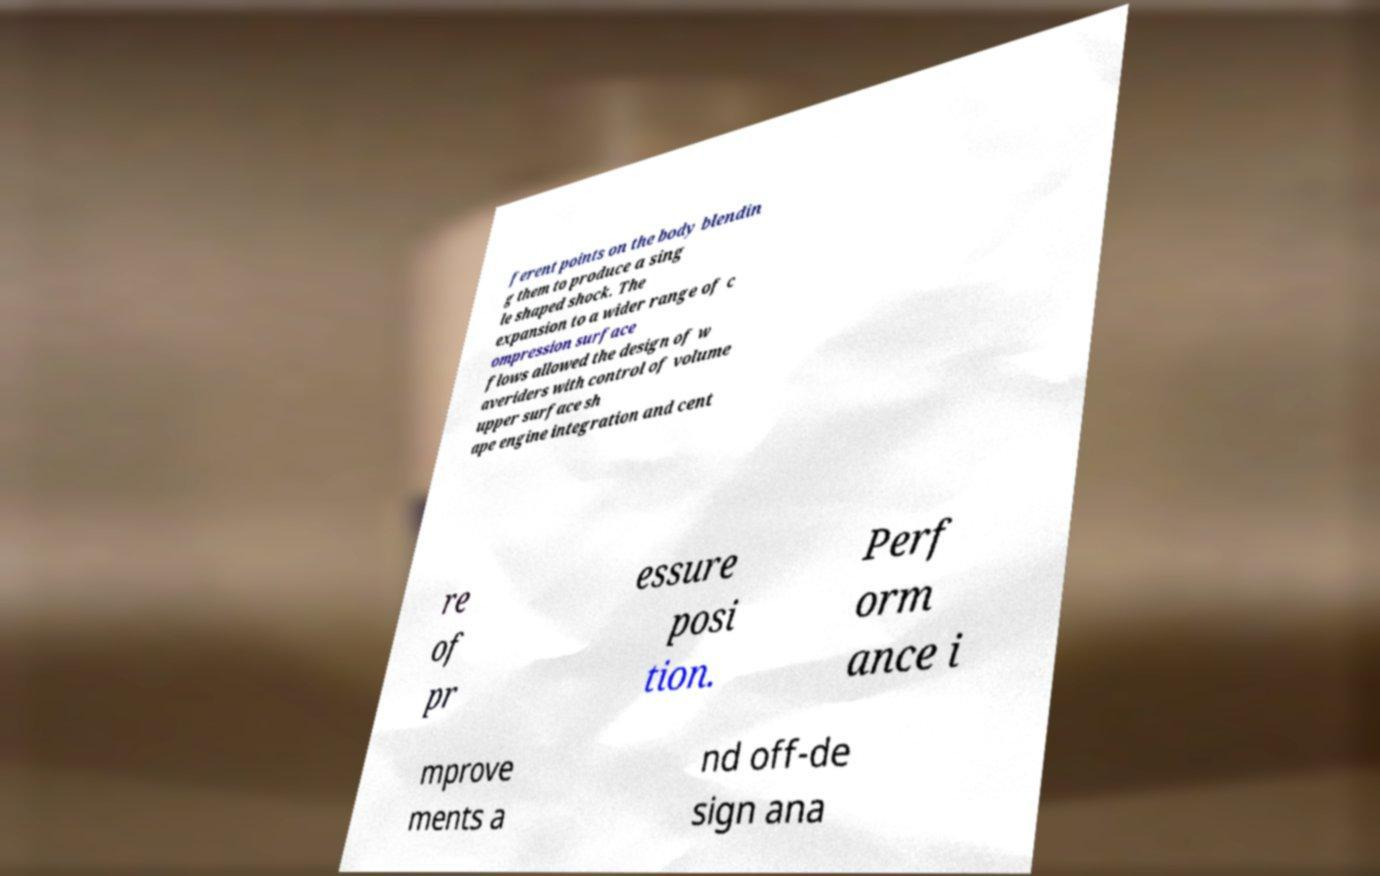Could you assist in decoding the text presented in this image and type it out clearly? ferent points on the body blendin g them to produce a sing le shaped shock. The expansion to a wider range of c ompression surface flows allowed the design of w averiders with control of volume upper surface sh ape engine integration and cent re of pr essure posi tion. Perf orm ance i mprove ments a nd off-de sign ana 